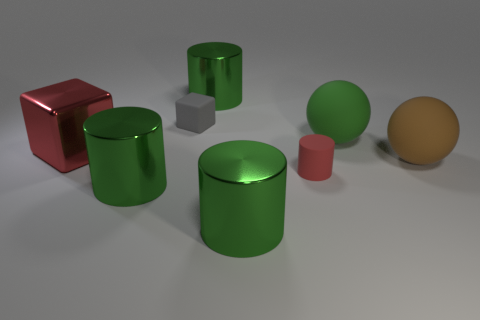Do the small rubber cylinder and the cube that is in front of the green matte sphere have the same color? Based on the image provided, the small rubber cylinder appears to have a shade of grey color, while the cube in front of the green matte sphere also exhibits a grey hue. While the lighting conditions might affect the perception of color, it can be said that both objects display similar colors in the given context. 